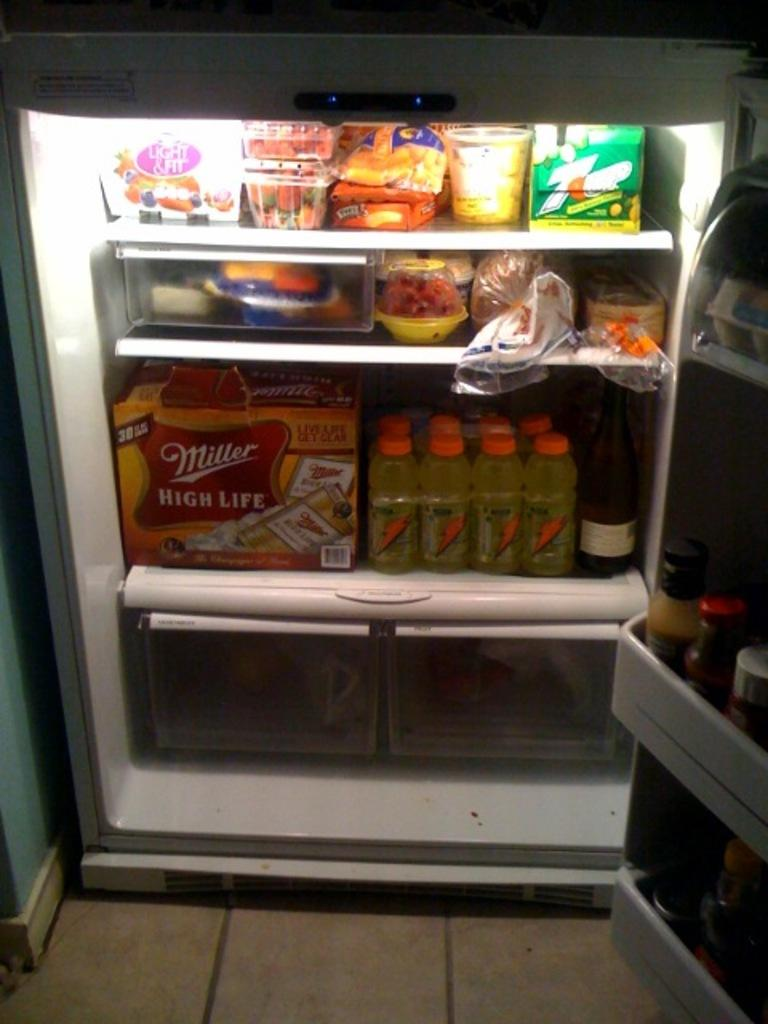<image>
Provide a brief description of the given image. An open refrigerator stocked with Miller High Life Beer, Gatorade and other items. 